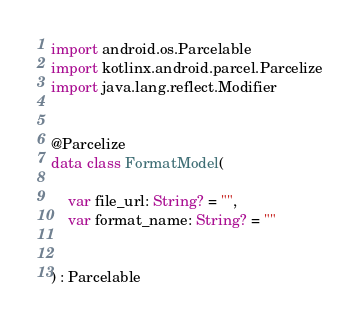<code> <loc_0><loc_0><loc_500><loc_500><_Kotlin_>import android.os.Parcelable
import kotlinx.android.parcel.Parcelize
import java.lang.reflect.Modifier


@Parcelize
data class FormatModel(

    var file_url: String? = "",
    var format_name: String? = ""


) : Parcelable</code> 